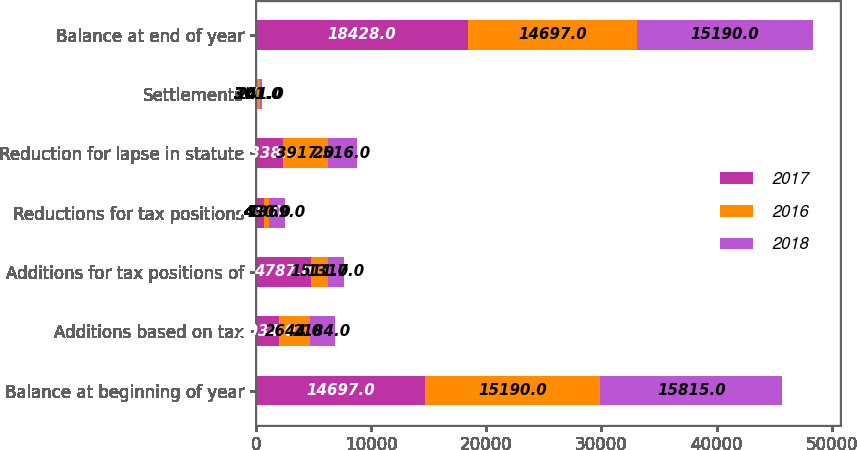Convert chart. <chart><loc_0><loc_0><loc_500><loc_500><stacked_bar_chart><ecel><fcel>Balance at beginning of year<fcel>Additions based on tax<fcel>Additions for tax positions of<fcel>Reductions for tax positions<fcel>Reduction for lapse in statute<fcel>Settlements<fcel>Balance at end of year<nl><fcel>2017<fcel>14697<fcel>2034<fcel>4787<fcel>725<fcel>2338<fcel>27<fcel>18428<nl><fcel>2016<fcel>15190<fcel>2644<fcel>1511<fcel>430<fcel>3917<fcel>301<fcel>14697<nl><fcel>2018<fcel>15815<fcel>2184<fcel>1317<fcel>1369<fcel>2516<fcel>241<fcel>15190<nl></chart> 